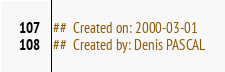Convert code to text. <code><loc_0><loc_0><loc_500><loc_500><_Nim_>##  Created on: 2000-03-01
##  Created by: Denis PASCAL</code> 